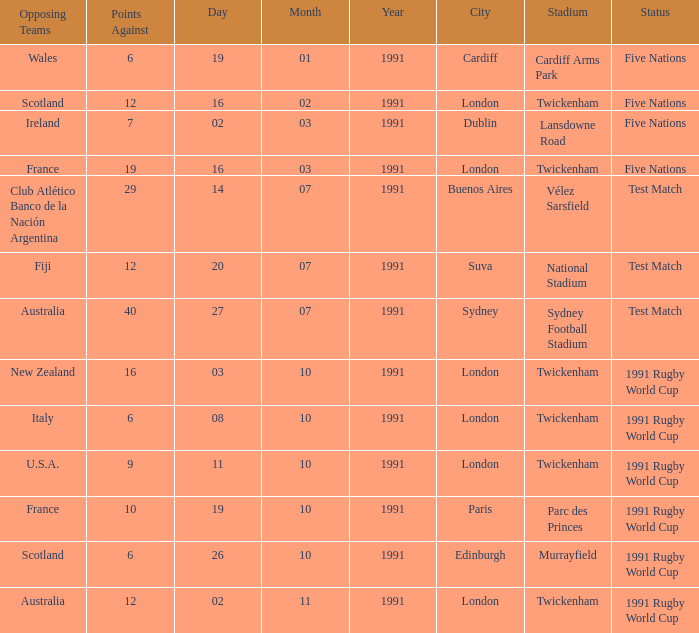On 27/07/1991, which team played against australia? 40.0. 